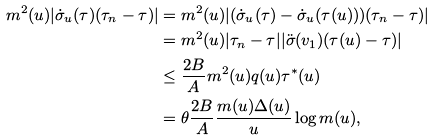Convert formula to latex. <formula><loc_0><loc_0><loc_500><loc_500>m ^ { 2 } ( u ) | \dot { \sigma } _ { u } ( \tau ) ( \tau _ { n } - \tau ) | & = m ^ { 2 } ( u ) | ( \dot { \sigma } _ { u } ( \tau ) - \dot { \sigma } _ { u } ( \tau ( u ) ) ) ( \tau _ { n } - \tau ) | \\ & = m ^ { 2 } ( u ) | \tau _ { n } - \tau | | \ddot { \sigma } ( v _ { 1 } ) ( \tau ( u ) - \tau ) | \\ & \leq \frac { 2 B } { A } m ^ { 2 } ( u ) q ( u ) \tau ^ { * } ( u ) \\ & = \theta \frac { 2 B } { A } \frac { m ( u ) \Delta ( u ) } { u } \log m ( u ) ,</formula> 